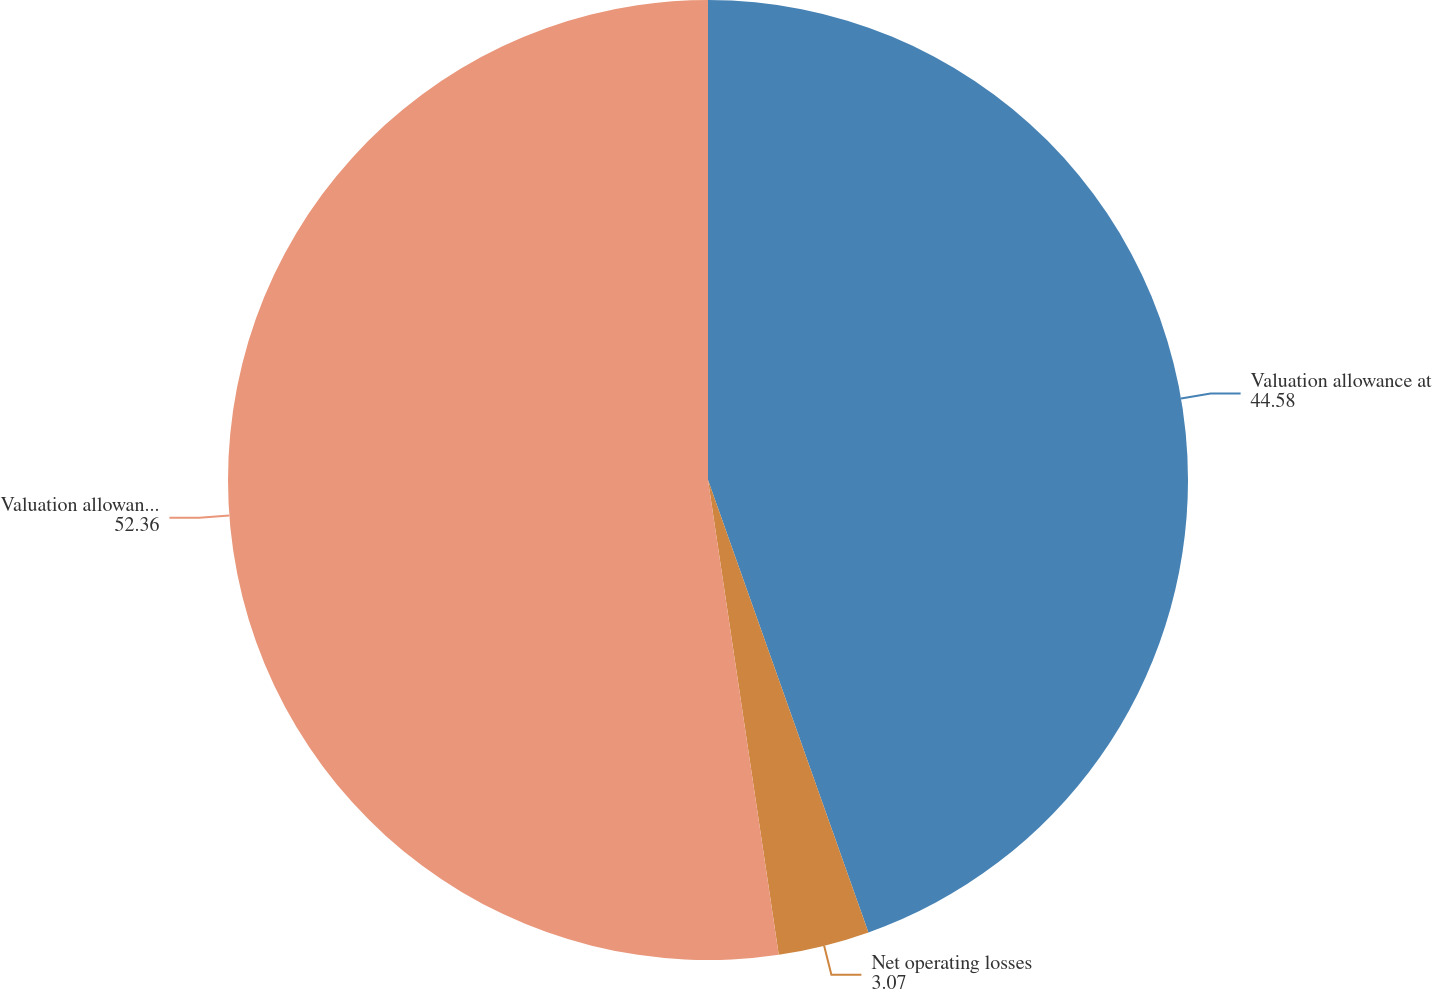Convert chart. <chart><loc_0><loc_0><loc_500><loc_500><pie_chart><fcel>Valuation allowance at<fcel>Net operating losses<fcel>Valuation allowance at end of<nl><fcel>44.58%<fcel>3.07%<fcel>52.36%<nl></chart> 